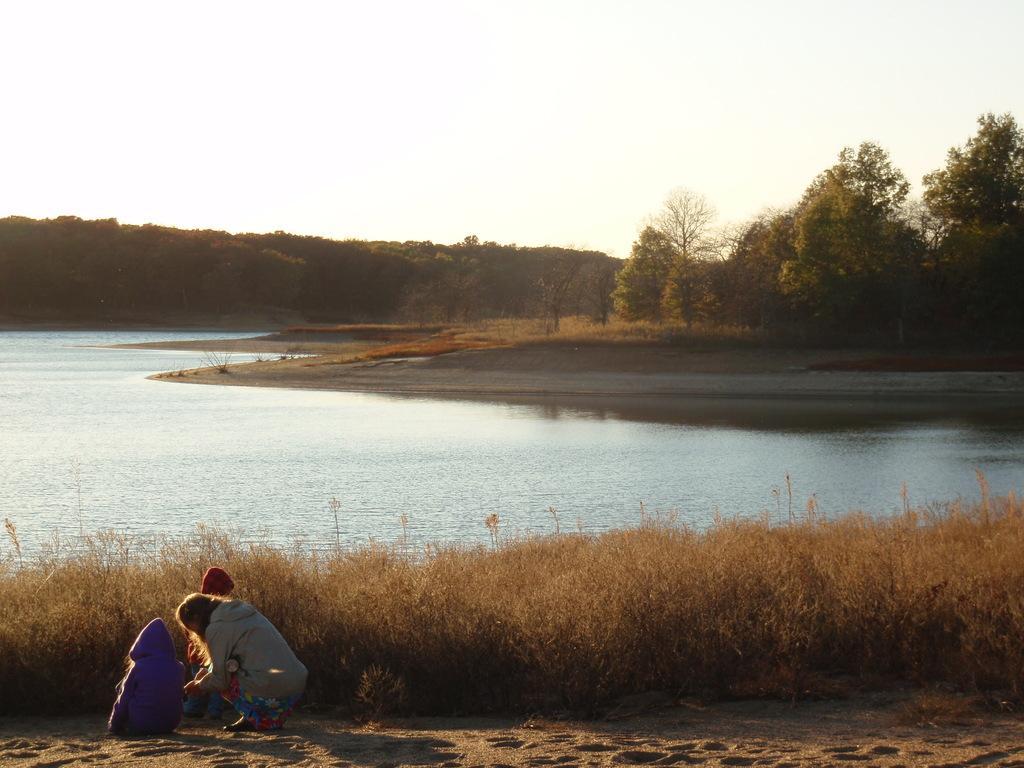Could you give a brief overview of what you see in this image? There is a river and around the river there are many trees and grass and in the front two people were sitting on the sand in front of the grass and a kid it is standing beside the woman who is sitting on her knees. 